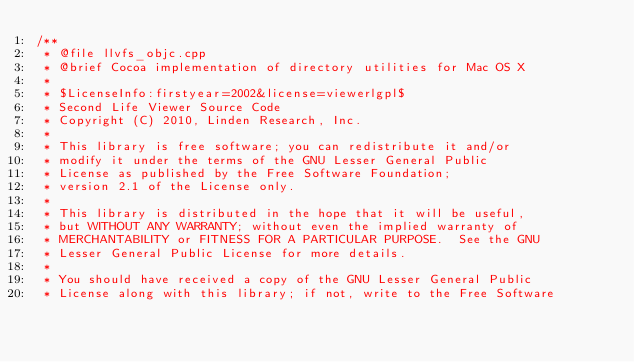Convert code to text. <code><loc_0><loc_0><loc_500><loc_500><_ObjectiveC_>/** 
 * @file llvfs_objc.cpp
 * @brief Cocoa implementation of directory utilities for Mac OS X
 *
 * $LicenseInfo:firstyear=2002&license=viewerlgpl$
 * Second Life Viewer Source Code
 * Copyright (C) 2010, Linden Research, Inc.
 * 
 * This library is free software; you can redistribute it and/or
 * modify it under the terms of the GNU Lesser General Public
 * License as published by the Free Software Foundation;
 * version 2.1 of the License only.
 * 
 * This library is distributed in the hope that it will be useful,
 * but WITHOUT ANY WARRANTY; without even the implied warranty of
 * MERCHANTABILITY or FITNESS FOR A PARTICULAR PURPOSE.  See the GNU
 * Lesser General Public License for more details.
 * 
 * You should have received a copy of the GNU Lesser General Public
 * License along with this library; if not, write to the Free Software</code> 